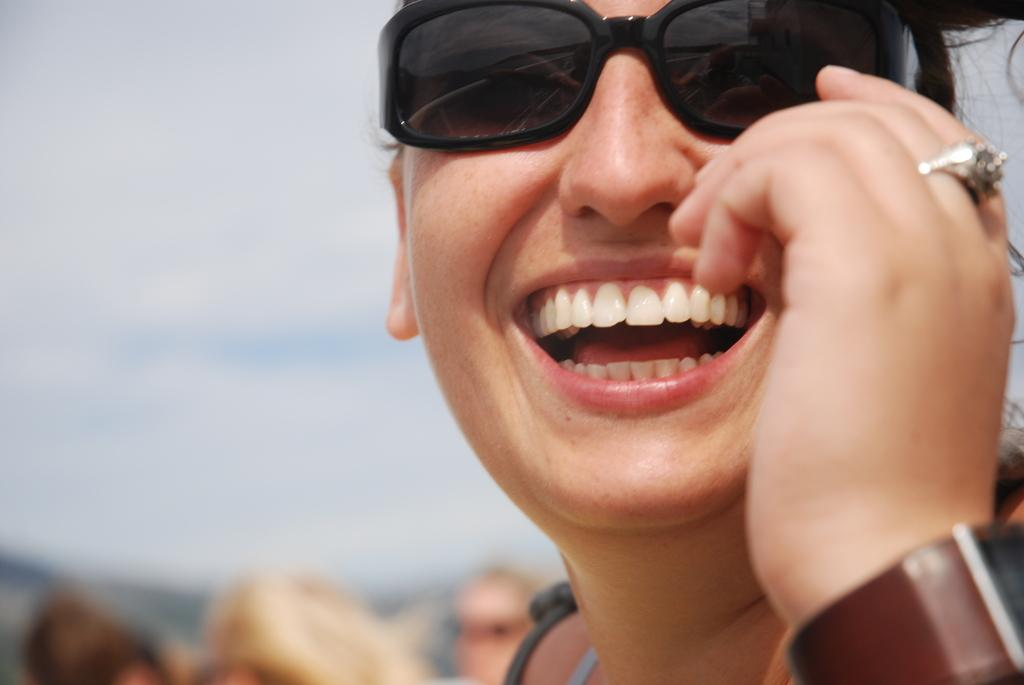Who is the main subject in the image? There is a person in the center of the image. What is the person doing in the image? The person is smiling. What accessory is the person wearing in the image? The person is wearing glasses. Can you describe the background of the image? The background of the image is blurred. What type of cake is the beggar holding in the image? There is no beggar or cake present in the image. How many stars can be seen in the image? There are no stars visible in the image. 